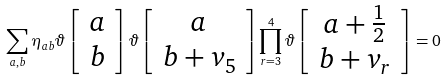Convert formula to latex. <formula><loc_0><loc_0><loc_500><loc_500>\sum _ { a , b } \eta _ { a b } \vartheta \left [ \begin{array} { c } a \\ b \end{array} \right ] \vartheta \left [ \begin{array} { c } a \\ b + v _ { 5 } \end{array} \right ] \prod _ { r = 3 } ^ { 4 } \vartheta \left [ \begin{array} { c } a + \frac { 1 } { 2 } \\ b + v _ { r } \end{array} \right ] = 0</formula> 